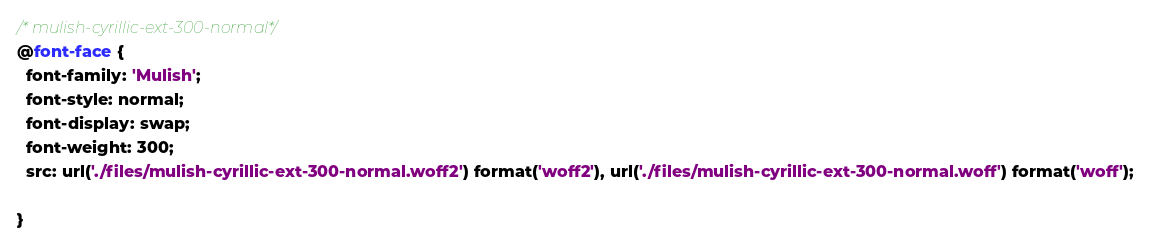<code> <loc_0><loc_0><loc_500><loc_500><_CSS_>/* mulish-cyrillic-ext-300-normal*/
@font-face {
  font-family: 'Mulish';
  font-style: normal;
  font-display: swap;
  font-weight: 300;
  src: url('./files/mulish-cyrillic-ext-300-normal.woff2') format('woff2'), url('./files/mulish-cyrillic-ext-300-normal.woff') format('woff');
  
}
</code> 